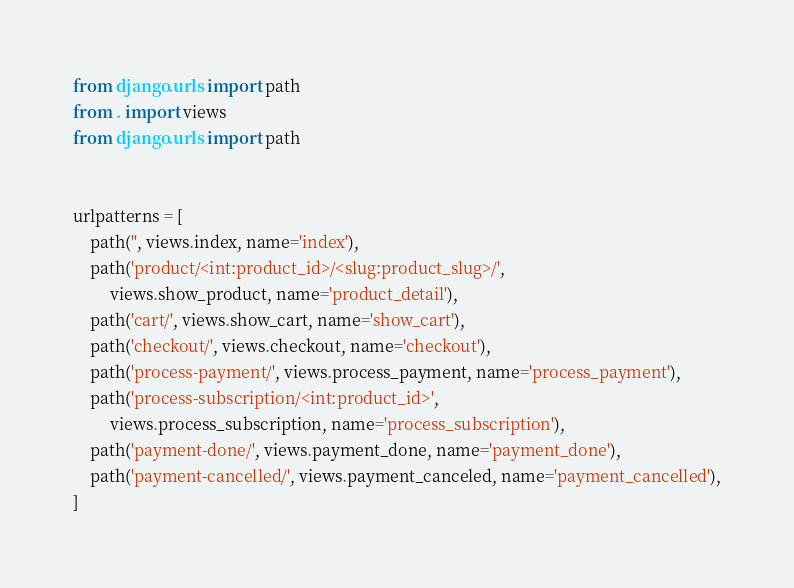<code> <loc_0><loc_0><loc_500><loc_500><_Python_>from django.urls import path
from . import views
from django.urls import path


urlpatterns = [
    path('', views.index, name='index'),
    path('product/<int:product_id>/<slug:product_slug>/',
         views.show_product, name='product_detail'),
    path('cart/', views.show_cart, name='show_cart'),
    path('checkout/', views.checkout, name='checkout'),
    path('process-payment/', views.process_payment, name='process_payment'),
    path('process-subscription/<int:product_id>',
         views.process_subscription, name='process_subscription'),
    path('payment-done/', views.payment_done, name='payment_done'),
    path('payment-cancelled/', views.payment_canceled, name='payment_cancelled'),
]
</code> 